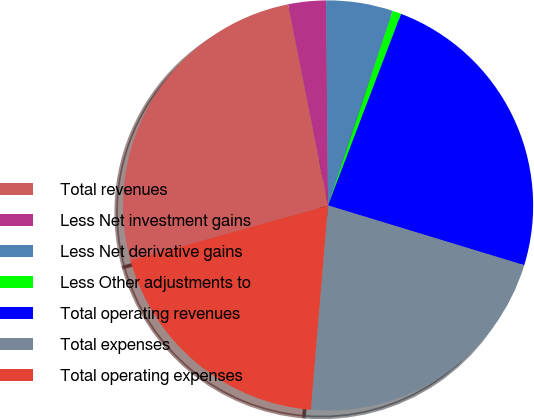Convert chart. <chart><loc_0><loc_0><loc_500><loc_500><pie_chart><fcel>Total revenues<fcel>Less Net investment gains<fcel>Less Net derivative gains<fcel>Less Other adjustments to<fcel>Total operating revenues<fcel>Total expenses<fcel>Total operating expenses<nl><fcel>26.19%<fcel>2.97%<fcel>5.26%<fcel>0.69%<fcel>23.91%<fcel>21.63%<fcel>19.35%<nl></chart> 